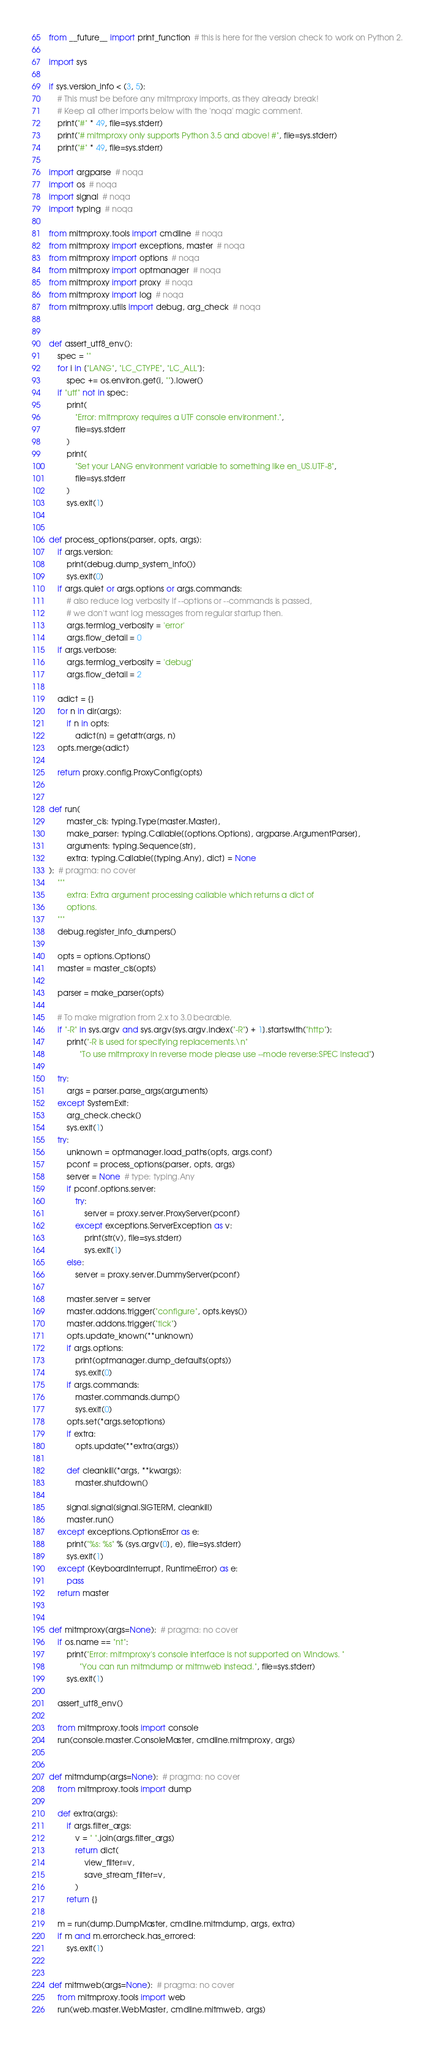<code> <loc_0><loc_0><loc_500><loc_500><_Python_>from __future__ import print_function  # this is here for the version check to work on Python 2.

import sys

if sys.version_info < (3, 5):
    # This must be before any mitmproxy imports, as they already break!
    # Keep all other imports below with the 'noqa' magic comment.
    print("#" * 49, file=sys.stderr)
    print("# mitmproxy only supports Python 3.5 and above! #", file=sys.stderr)
    print("#" * 49, file=sys.stderr)

import argparse  # noqa
import os  # noqa
import signal  # noqa
import typing  # noqa

from mitmproxy.tools import cmdline  # noqa
from mitmproxy import exceptions, master  # noqa
from mitmproxy import options  # noqa
from mitmproxy import optmanager  # noqa
from mitmproxy import proxy  # noqa
from mitmproxy import log  # noqa
from mitmproxy.utils import debug, arg_check  # noqa


def assert_utf8_env():
    spec = ""
    for i in ["LANG", "LC_CTYPE", "LC_ALL"]:
        spec += os.environ.get(i, "").lower()
    if "utf" not in spec:
        print(
            "Error: mitmproxy requires a UTF console environment.",
            file=sys.stderr
        )
        print(
            "Set your LANG environment variable to something like en_US.UTF-8",
            file=sys.stderr
        )
        sys.exit(1)


def process_options(parser, opts, args):
    if args.version:
        print(debug.dump_system_info())
        sys.exit(0)
    if args.quiet or args.options or args.commands:
        # also reduce log verbosity if --options or --commands is passed,
        # we don't want log messages from regular startup then.
        args.termlog_verbosity = 'error'
        args.flow_detail = 0
    if args.verbose:
        args.termlog_verbosity = 'debug'
        args.flow_detail = 2

    adict = {}
    for n in dir(args):
        if n in opts:
            adict[n] = getattr(args, n)
    opts.merge(adict)

    return proxy.config.ProxyConfig(opts)


def run(
        master_cls: typing.Type[master.Master],
        make_parser: typing.Callable[[options.Options], argparse.ArgumentParser],
        arguments: typing.Sequence[str],
        extra: typing.Callable[[typing.Any], dict] = None
):  # pragma: no cover
    """
        extra: Extra argument processing callable which returns a dict of
        options.
    """
    debug.register_info_dumpers()

    opts = options.Options()
    master = master_cls(opts)

    parser = make_parser(opts)

    # To make migration from 2.x to 3.0 bearable.
    if "-R" in sys.argv and sys.argv[sys.argv.index("-R") + 1].startswith("http"):
        print("-R is used for specifying replacements.\n"
              "To use mitmproxy in reverse mode please use --mode reverse:SPEC instead")

    try:
        args = parser.parse_args(arguments)
    except SystemExit:
        arg_check.check()
        sys.exit(1)
    try:
        unknown = optmanager.load_paths(opts, args.conf)
        pconf = process_options(parser, opts, args)
        server = None  # type: typing.Any
        if pconf.options.server:
            try:
                server = proxy.server.ProxyServer(pconf)
            except exceptions.ServerException as v:
                print(str(v), file=sys.stderr)
                sys.exit(1)
        else:
            server = proxy.server.DummyServer(pconf)

        master.server = server
        master.addons.trigger("configure", opts.keys())
        master.addons.trigger("tick")
        opts.update_known(**unknown)
        if args.options:
            print(optmanager.dump_defaults(opts))
            sys.exit(0)
        if args.commands:
            master.commands.dump()
            sys.exit(0)
        opts.set(*args.setoptions)
        if extra:
            opts.update(**extra(args))

        def cleankill(*args, **kwargs):
            master.shutdown()

        signal.signal(signal.SIGTERM, cleankill)
        master.run()
    except exceptions.OptionsError as e:
        print("%s: %s" % (sys.argv[0], e), file=sys.stderr)
        sys.exit(1)
    except (KeyboardInterrupt, RuntimeError) as e:
        pass
    return master


def mitmproxy(args=None):  # pragma: no cover
    if os.name == "nt":
        print("Error: mitmproxy's console interface is not supported on Windows. "
              "You can run mitmdump or mitmweb instead.", file=sys.stderr)
        sys.exit(1)

    assert_utf8_env()

    from mitmproxy.tools import console
    run(console.master.ConsoleMaster, cmdline.mitmproxy, args)


def mitmdump(args=None):  # pragma: no cover
    from mitmproxy.tools import dump

    def extra(args):
        if args.filter_args:
            v = " ".join(args.filter_args)
            return dict(
                view_filter=v,
                save_stream_filter=v,
            )
        return {}

    m = run(dump.DumpMaster, cmdline.mitmdump, args, extra)
    if m and m.errorcheck.has_errored:
        sys.exit(1)


def mitmweb(args=None):  # pragma: no cover
    from mitmproxy.tools import web
    run(web.master.WebMaster, cmdline.mitmweb, args)
</code> 